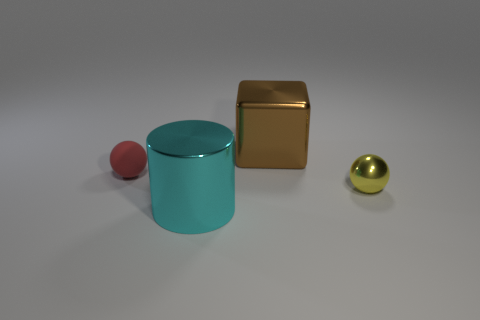Is there any other thing that has the same material as the small red sphere?
Your answer should be compact. No. The brown block that is the same material as the big cylinder is what size?
Give a very brief answer. Large. Is the size of the matte object the same as the shiny sphere?
Offer a terse response. Yes. The block that is the same size as the cyan shiny thing is what color?
Offer a very short reply. Brown. Does the cyan shiny object have the same size as the metallic thing that is behind the tiny shiny object?
Provide a succinct answer. Yes. How many things are large shiny cylinders or small balls on the left side of the tiny yellow object?
Offer a terse response. 2. There is a object behind the tiny red matte sphere; is it the same size as the sphere that is right of the metallic block?
Ensure brevity in your answer.  No. Are there any big green objects made of the same material as the large cyan object?
Offer a very short reply. No. What is the shape of the large cyan thing?
Provide a short and direct response. Cylinder. What is the shape of the object in front of the tiny sphere to the right of the brown metal block?
Give a very brief answer. Cylinder. 